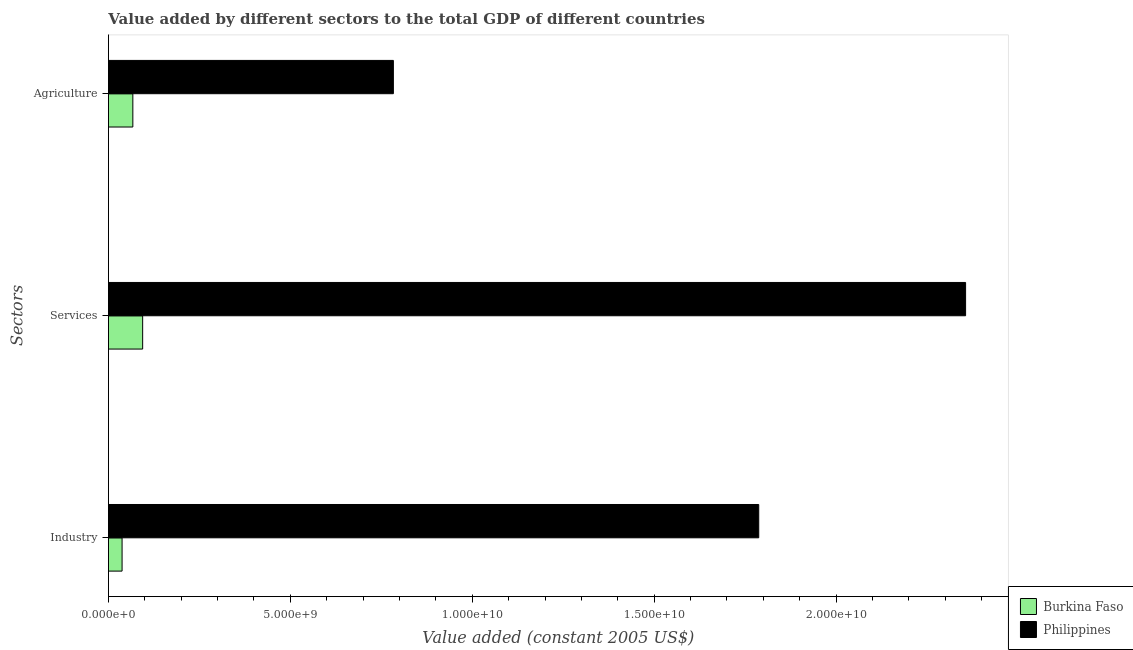How many different coloured bars are there?
Provide a succinct answer. 2. Are the number of bars per tick equal to the number of legend labels?
Offer a terse response. Yes. Are the number of bars on each tick of the Y-axis equal?
Offer a terse response. Yes. How many bars are there on the 1st tick from the bottom?
Offer a very short reply. 2. What is the label of the 2nd group of bars from the top?
Your response must be concise. Services. What is the value added by services in Philippines?
Keep it short and to the point. 2.36e+1. Across all countries, what is the maximum value added by industrial sector?
Give a very brief answer. 1.79e+1. Across all countries, what is the minimum value added by industrial sector?
Offer a terse response. 3.75e+08. In which country was the value added by services minimum?
Offer a terse response. Burkina Faso. What is the total value added by industrial sector in the graph?
Offer a very short reply. 1.82e+1. What is the difference between the value added by industrial sector in Burkina Faso and that in Philippines?
Give a very brief answer. -1.75e+1. What is the difference between the value added by industrial sector in Philippines and the value added by agricultural sector in Burkina Faso?
Keep it short and to the point. 1.72e+1. What is the average value added by industrial sector per country?
Offer a terse response. 9.12e+09. What is the difference between the value added by services and value added by agricultural sector in Burkina Faso?
Your answer should be very brief. 2.70e+08. What is the ratio of the value added by agricultural sector in Burkina Faso to that in Philippines?
Provide a succinct answer. 0.09. Is the difference between the value added by services in Philippines and Burkina Faso greater than the difference between the value added by agricultural sector in Philippines and Burkina Faso?
Ensure brevity in your answer.  Yes. What is the difference between the highest and the second highest value added by services?
Provide a succinct answer. 2.26e+1. What is the difference between the highest and the lowest value added by services?
Your response must be concise. 2.26e+1. In how many countries, is the value added by agricultural sector greater than the average value added by agricultural sector taken over all countries?
Offer a terse response. 1. What does the 2nd bar from the top in Industry represents?
Give a very brief answer. Burkina Faso. What does the 1st bar from the bottom in Agriculture represents?
Offer a very short reply. Burkina Faso. Is it the case that in every country, the sum of the value added by industrial sector and value added by services is greater than the value added by agricultural sector?
Make the answer very short. Yes. Are the values on the major ticks of X-axis written in scientific E-notation?
Offer a very short reply. Yes. Does the graph contain any zero values?
Make the answer very short. No. How many legend labels are there?
Your response must be concise. 2. What is the title of the graph?
Your answer should be very brief. Value added by different sectors to the total GDP of different countries. Does "Suriname" appear as one of the legend labels in the graph?
Make the answer very short. No. What is the label or title of the X-axis?
Your answer should be very brief. Value added (constant 2005 US$). What is the label or title of the Y-axis?
Provide a short and direct response. Sectors. What is the Value added (constant 2005 US$) of Burkina Faso in Industry?
Provide a short and direct response. 3.75e+08. What is the Value added (constant 2005 US$) of Philippines in Industry?
Your answer should be very brief. 1.79e+1. What is the Value added (constant 2005 US$) in Burkina Faso in Services?
Your answer should be very brief. 9.41e+08. What is the Value added (constant 2005 US$) in Philippines in Services?
Ensure brevity in your answer.  2.36e+1. What is the Value added (constant 2005 US$) in Burkina Faso in Agriculture?
Your response must be concise. 6.71e+08. What is the Value added (constant 2005 US$) in Philippines in Agriculture?
Keep it short and to the point. 7.83e+09. Across all Sectors, what is the maximum Value added (constant 2005 US$) in Burkina Faso?
Offer a terse response. 9.41e+08. Across all Sectors, what is the maximum Value added (constant 2005 US$) of Philippines?
Provide a short and direct response. 2.36e+1. Across all Sectors, what is the minimum Value added (constant 2005 US$) of Burkina Faso?
Offer a terse response. 3.75e+08. Across all Sectors, what is the minimum Value added (constant 2005 US$) of Philippines?
Provide a short and direct response. 7.83e+09. What is the total Value added (constant 2005 US$) of Burkina Faso in the graph?
Keep it short and to the point. 1.99e+09. What is the total Value added (constant 2005 US$) of Philippines in the graph?
Provide a succinct answer. 4.93e+1. What is the difference between the Value added (constant 2005 US$) in Burkina Faso in Industry and that in Services?
Offer a very short reply. -5.66e+08. What is the difference between the Value added (constant 2005 US$) of Philippines in Industry and that in Services?
Offer a terse response. -5.69e+09. What is the difference between the Value added (constant 2005 US$) in Burkina Faso in Industry and that in Agriculture?
Offer a very short reply. -2.96e+08. What is the difference between the Value added (constant 2005 US$) in Philippines in Industry and that in Agriculture?
Keep it short and to the point. 1.00e+1. What is the difference between the Value added (constant 2005 US$) of Burkina Faso in Services and that in Agriculture?
Give a very brief answer. 2.70e+08. What is the difference between the Value added (constant 2005 US$) of Philippines in Services and that in Agriculture?
Your answer should be compact. 1.57e+1. What is the difference between the Value added (constant 2005 US$) in Burkina Faso in Industry and the Value added (constant 2005 US$) in Philippines in Services?
Make the answer very short. -2.32e+1. What is the difference between the Value added (constant 2005 US$) in Burkina Faso in Industry and the Value added (constant 2005 US$) in Philippines in Agriculture?
Provide a short and direct response. -7.46e+09. What is the difference between the Value added (constant 2005 US$) of Burkina Faso in Services and the Value added (constant 2005 US$) of Philippines in Agriculture?
Your answer should be very brief. -6.89e+09. What is the average Value added (constant 2005 US$) in Burkina Faso per Sectors?
Ensure brevity in your answer.  6.62e+08. What is the average Value added (constant 2005 US$) of Philippines per Sectors?
Provide a short and direct response. 1.64e+1. What is the difference between the Value added (constant 2005 US$) in Burkina Faso and Value added (constant 2005 US$) in Philippines in Industry?
Your answer should be compact. -1.75e+1. What is the difference between the Value added (constant 2005 US$) in Burkina Faso and Value added (constant 2005 US$) in Philippines in Services?
Keep it short and to the point. -2.26e+1. What is the difference between the Value added (constant 2005 US$) in Burkina Faso and Value added (constant 2005 US$) in Philippines in Agriculture?
Your answer should be compact. -7.16e+09. What is the ratio of the Value added (constant 2005 US$) of Burkina Faso in Industry to that in Services?
Ensure brevity in your answer.  0.4. What is the ratio of the Value added (constant 2005 US$) in Philippines in Industry to that in Services?
Provide a short and direct response. 0.76. What is the ratio of the Value added (constant 2005 US$) of Burkina Faso in Industry to that in Agriculture?
Offer a very short reply. 0.56. What is the ratio of the Value added (constant 2005 US$) of Philippines in Industry to that in Agriculture?
Ensure brevity in your answer.  2.28. What is the ratio of the Value added (constant 2005 US$) of Burkina Faso in Services to that in Agriculture?
Your response must be concise. 1.4. What is the ratio of the Value added (constant 2005 US$) in Philippines in Services to that in Agriculture?
Your response must be concise. 3.01. What is the difference between the highest and the second highest Value added (constant 2005 US$) of Burkina Faso?
Offer a very short reply. 2.70e+08. What is the difference between the highest and the second highest Value added (constant 2005 US$) of Philippines?
Offer a very short reply. 5.69e+09. What is the difference between the highest and the lowest Value added (constant 2005 US$) in Burkina Faso?
Offer a very short reply. 5.66e+08. What is the difference between the highest and the lowest Value added (constant 2005 US$) in Philippines?
Keep it short and to the point. 1.57e+1. 